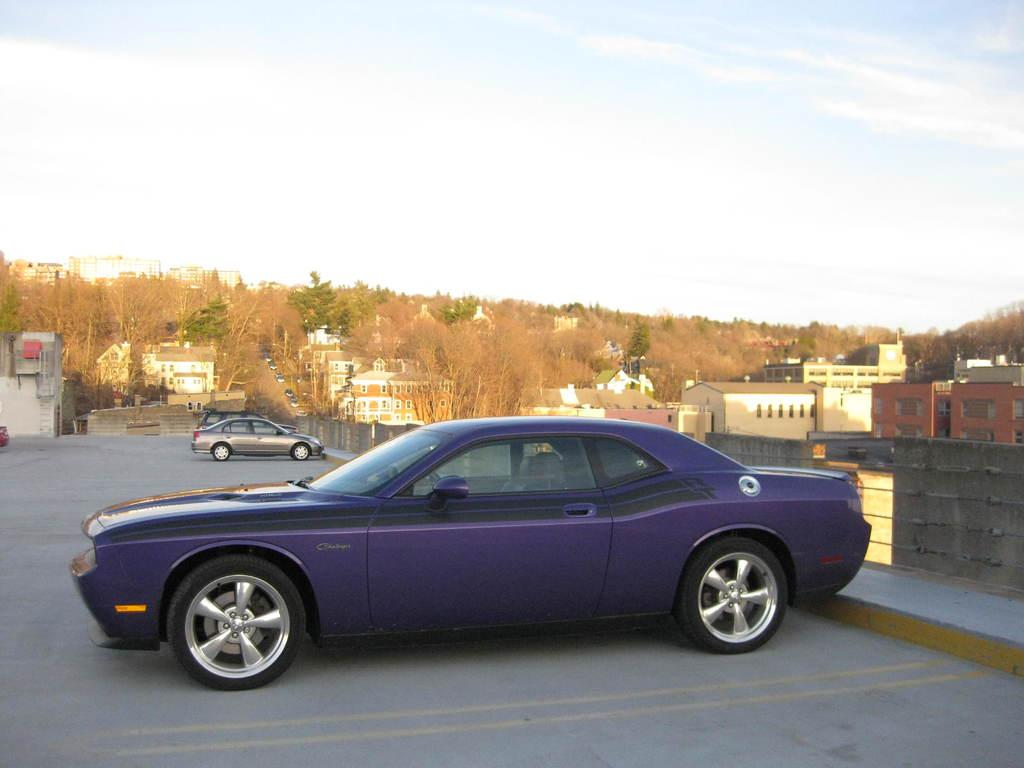What type of structures can be seen in the image? There are many buildings in the image. What other elements can be seen in the image besides buildings? There are trees, vehicles, and a wall visible in the image. What is visible in the background of the image? The sky is visible in the background of the image. What can be observed in the sky? Clouds are present in the sky. Can you tell me how many clover leaves are growing on the trees in the image? There are no clover leaves growing on the trees in the image, as trees typically have leaves specific to their species. --- 